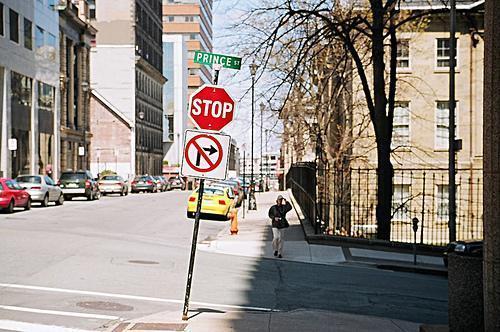How many traffic signs are visible?
Give a very brief answer. 2. How many people are in the picture?
Give a very brief answer. 1. 